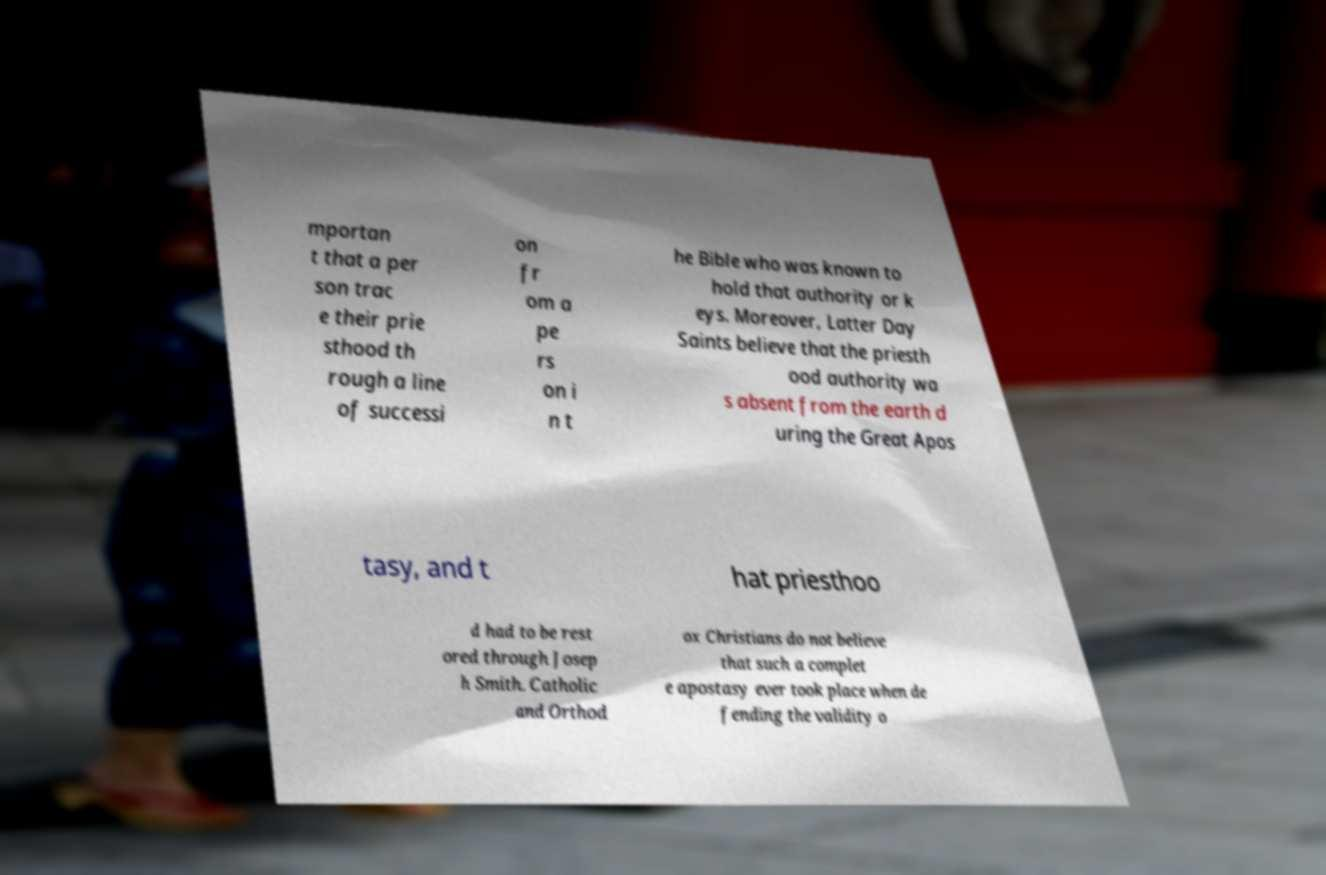I need the written content from this picture converted into text. Can you do that? mportan t that a per son trac e their prie sthood th rough a line of successi on fr om a pe rs on i n t he Bible who was known to hold that authority or k eys. Moreover, Latter Day Saints believe that the priesth ood authority wa s absent from the earth d uring the Great Apos tasy, and t hat priesthoo d had to be rest ored through Josep h Smith. Catholic and Orthod ox Christians do not believe that such a complet e apostasy ever took place when de fending the validity o 